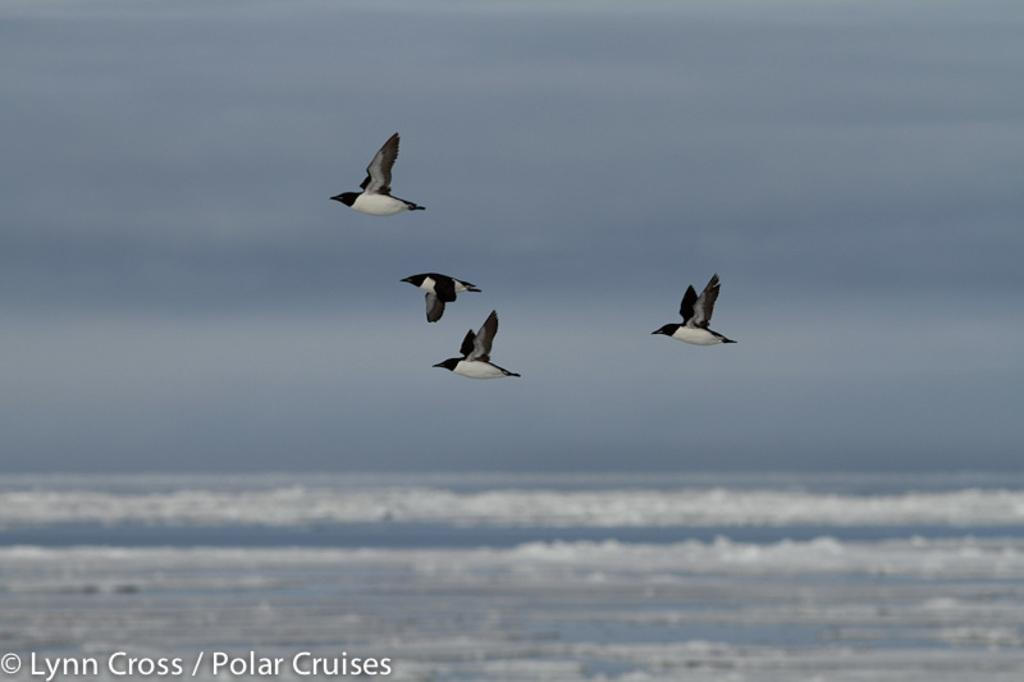How many birds are present in the image? There are four birds in the image. What are the birds doing in the image? The birds are flying in the sky. What else can be seen in the sky besides the birds? There are clouds in the sky. What is visible in the background of the image? Water is visible in the background of the image. What type of peace symbol can be seen on the partner's shirt in the image? There is no partner or shirt present in the image, and therefore no peace symbol can be observed. 